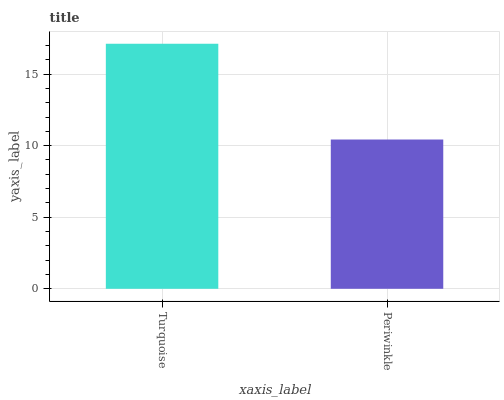Is Periwinkle the minimum?
Answer yes or no. Yes. Is Turquoise the maximum?
Answer yes or no. Yes. Is Periwinkle the maximum?
Answer yes or no. No. Is Turquoise greater than Periwinkle?
Answer yes or no. Yes. Is Periwinkle less than Turquoise?
Answer yes or no. Yes. Is Periwinkle greater than Turquoise?
Answer yes or no. No. Is Turquoise less than Periwinkle?
Answer yes or no. No. Is Turquoise the high median?
Answer yes or no. Yes. Is Periwinkle the low median?
Answer yes or no. Yes. Is Periwinkle the high median?
Answer yes or no. No. Is Turquoise the low median?
Answer yes or no. No. 